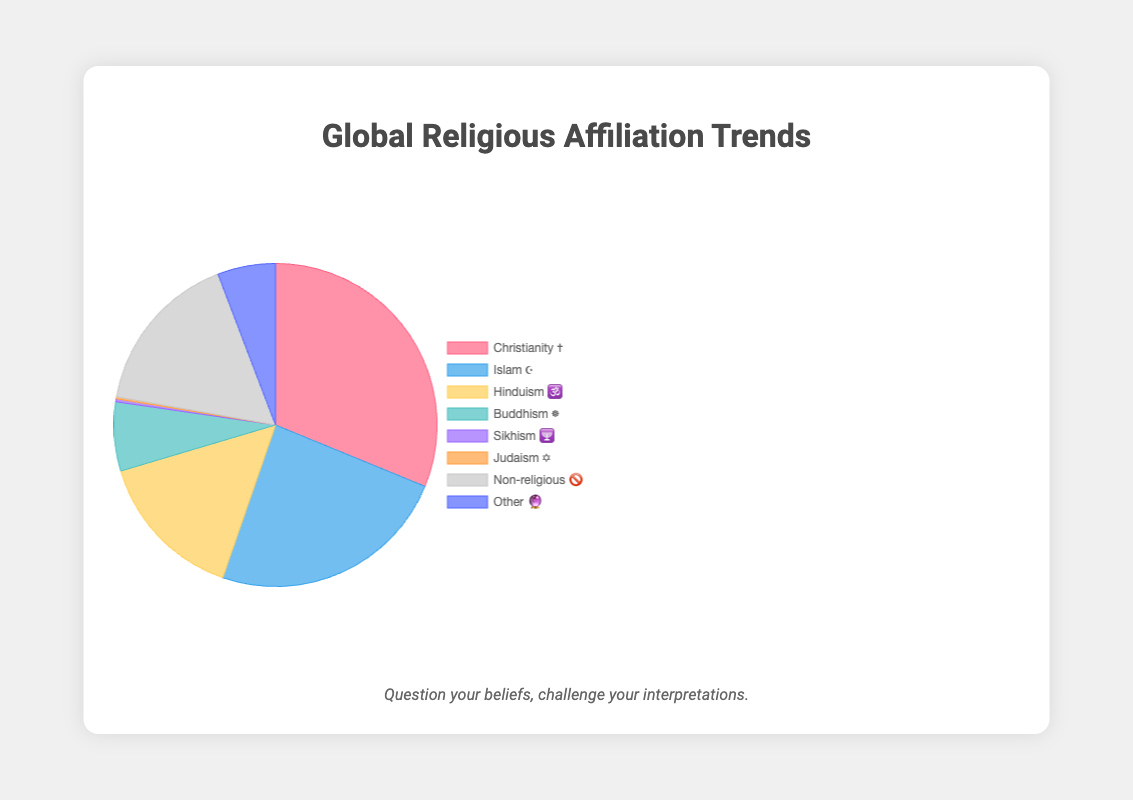What religion has the largest percentage according to the chart? The largest percentage corresponds to the religion with the highest segment in the pie chart, which is represented by Christianity (✝️) with 31.2%.
Answer: Christianity ✝️ What is the percentage difference between Non-religious (🚫) and Islam (☪️)? Subtract the percentage of Non-religious (16.4%) from that of Islam (24.1%). 24.1% - 16.4% = 7.7%.
Answer: 7.7% Which two religions have a growing trend and the smallest percentages? Identify the religions with a "growing" trend. The chart shows that Islam ☪️ and Sikhism 🕎 are growing. Among these, Sikhism has 0.3% and Islam has 24.1%. Thus, Sikhism and Islam.
Answer: Sikhism 🕎 and Islam ☪️ Arrange the religions with a stable trend in decreasing order of their percentages. Identify the religions with the "stable" trend. Hinduism 🕉️ (15.1%), Buddhism ☸️ (6.9%), Judaism ✡️ (0.2%), and Other 🔮 (5.8%) have stable trends. Arranging these in decreasing order gives Hinduism, Buddhism, Other, and Judaism.
Answer: Hinduism 🕉️, Buddhism ☸️, Other 🔮, Judaism ✡️ What is the sum of the percentages for all religions with a stable trend? Add the percentages of all religions with a "stable" trend: Hinduism (15.1%), Buddhism (6.9%), Judaism (0.2%), and Other (5.8%). 15.1% + 6.9% + 0.2% + 5.8% = 28%.
Answer: 28% Which religion has a declining trend? Look for the religion marked as "declining" in trend. Christianity (✝️) has a declining trend.
Answer: Christianity ✝️ Out of Buddhism ☸️ and Non-religious 🚫, which has a higher percentage? Compare the percentage values of Buddhism (6.9%) and Non-religious (16.4%). Non-religious has a higher percentage.
Answer: Non-religious 🚫 What is the title of the figure? The title of the figure, located at the top, is 'Global Religious Affiliation Trends'.
Answer: Global Religious Affiliation Trends If 3% of the population were to move from Christianity ✝️ to Non-religious 🚫, what would the new percentages be for each? Subtract 3% from Christianity (31.2%) and add it to Non-religious (16.4%): New Christianity percentage = 31.2% - 3% = 28.2%, New Non-religious percentage = 16.4% + 3% = 19.4%.
Answer: Christianity ✝️: 28.2%, Non-religious 🚫: 19.4% 